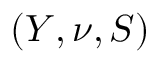<formula> <loc_0><loc_0><loc_500><loc_500>( Y , \nu , S )</formula> 